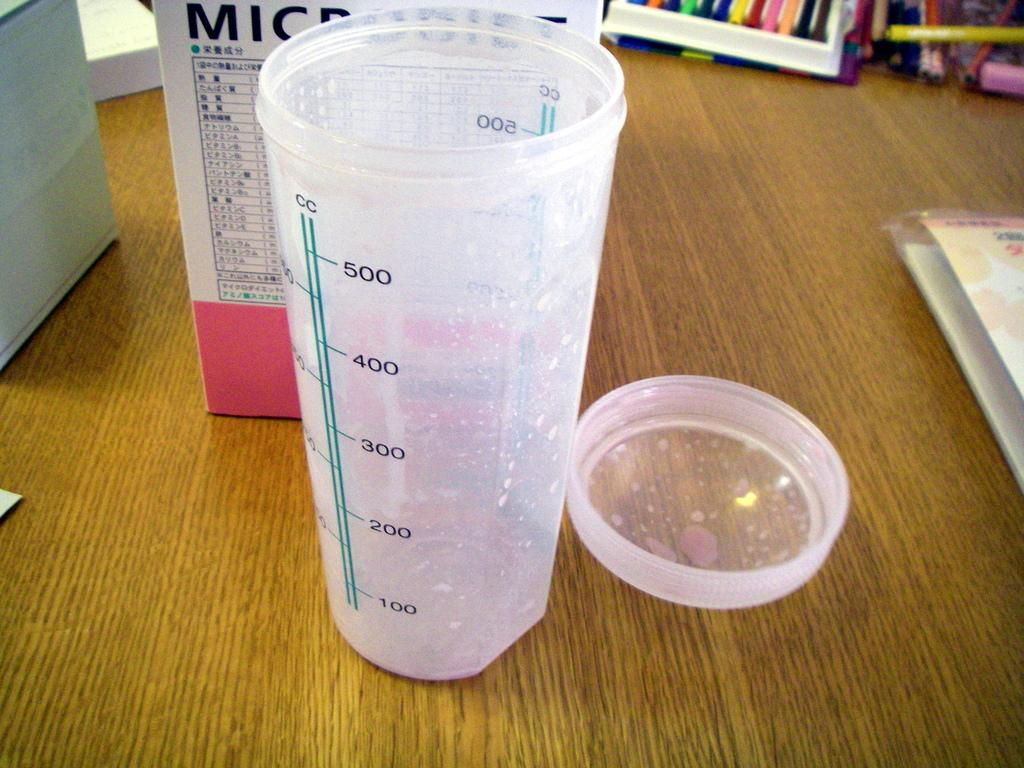Provide a one-sentence caption for the provided image. A plastic container shows the number is CCs it contains. 